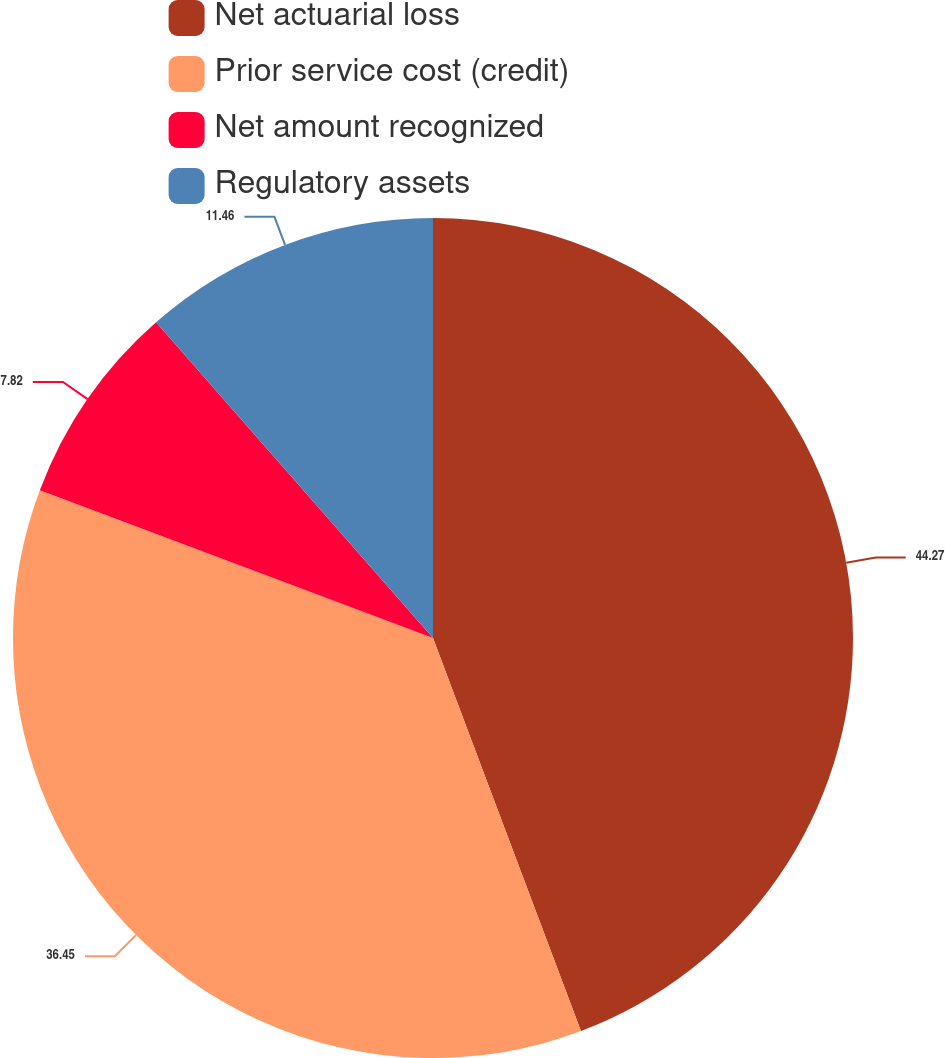Convert chart. <chart><loc_0><loc_0><loc_500><loc_500><pie_chart><fcel>Net actuarial loss<fcel>Prior service cost (credit)<fcel>Net amount recognized<fcel>Regulatory assets<nl><fcel>44.27%<fcel>36.45%<fcel>7.82%<fcel>11.46%<nl></chart> 